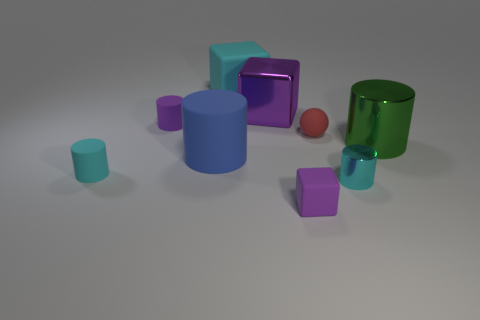Is there any other thing of the same color as the small rubber cube?
Offer a terse response. Yes. There is a blue object in front of the big rubber object behind the large cylinder that is behind the blue cylinder; how big is it?
Keep it short and to the point. Large. How many other objects are there of the same material as the small purple cylinder?
Your response must be concise. 5. What color is the big metallic thing that is in front of the purple matte cylinder?
Make the answer very short. Green. There is a purple thing behind the small purple matte cylinder in front of the matte cube behind the green metallic thing; what is its material?
Your response must be concise. Metal. Are there any gray rubber things that have the same shape as the large cyan rubber object?
Provide a succinct answer. No. There is a shiny thing that is the same size as the red matte sphere; what is its shape?
Offer a terse response. Cylinder. What number of small rubber objects are behind the red object and right of the blue cylinder?
Ensure brevity in your answer.  0. Is the number of small purple objects on the left side of the large cyan block less than the number of cyan rubber cylinders?
Make the answer very short. No. Are there any cyan shiny things that have the same size as the blue cylinder?
Keep it short and to the point. No. 